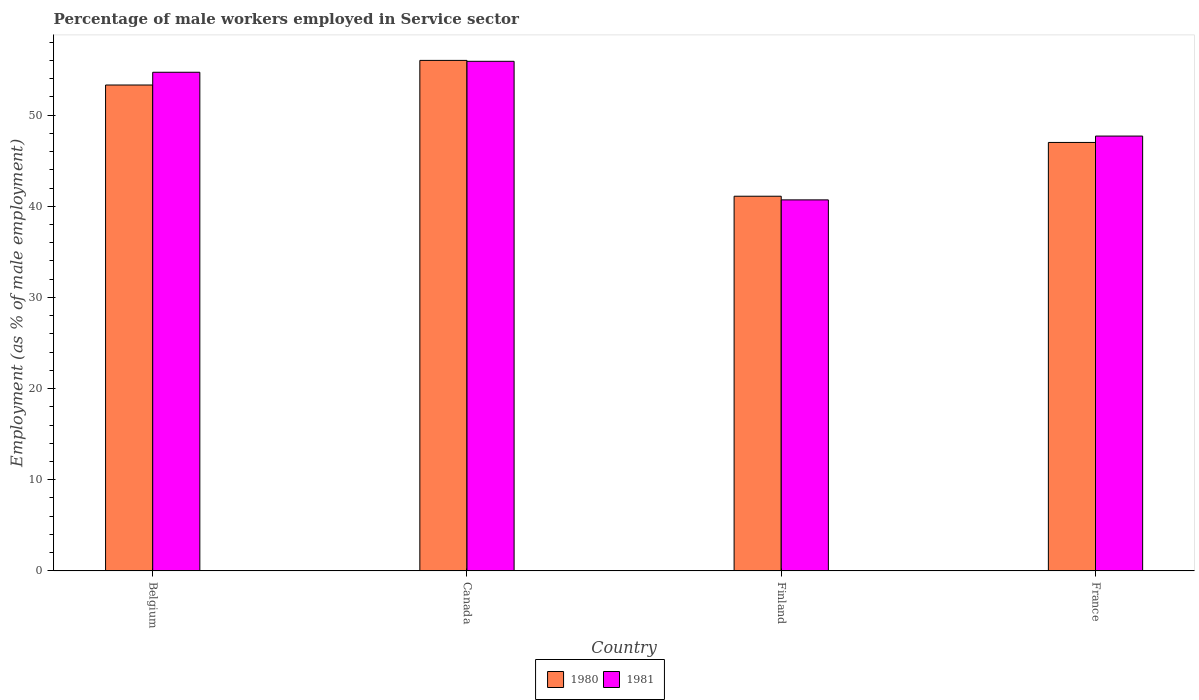How many different coloured bars are there?
Give a very brief answer. 2. How many groups of bars are there?
Ensure brevity in your answer.  4. Are the number of bars per tick equal to the number of legend labels?
Keep it short and to the point. Yes. Are the number of bars on each tick of the X-axis equal?
Offer a very short reply. Yes. How many bars are there on the 2nd tick from the right?
Your answer should be very brief. 2. What is the label of the 3rd group of bars from the left?
Ensure brevity in your answer.  Finland. What is the percentage of male workers employed in Service sector in 1981 in Canada?
Keep it short and to the point. 55.9. Across all countries, what is the maximum percentage of male workers employed in Service sector in 1981?
Provide a succinct answer. 55.9. Across all countries, what is the minimum percentage of male workers employed in Service sector in 1980?
Your answer should be compact. 41.1. In which country was the percentage of male workers employed in Service sector in 1981 maximum?
Provide a succinct answer. Canada. In which country was the percentage of male workers employed in Service sector in 1980 minimum?
Provide a short and direct response. Finland. What is the total percentage of male workers employed in Service sector in 1980 in the graph?
Make the answer very short. 197.4. What is the difference between the percentage of male workers employed in Service sector in 1981 in Finland and the percentage of male workers employed in Service sector in 1980 in Canada?
Keep it short and to the point. -15.3. What is the average percentage of male workers employed in Service sector in 1981 per country?
Keep it short and to the point. 49.75. What is the difference between the percentage of male workers employed in Service sector of/in 1980 and percentage of male workers employed in Service sector of/in 1981 in Canada?
Offer a terse response. 0.1. What is the ratio of the percentage of male workers employed in Service sector in 1981 in Canada to that in Finland?
Offer a terse response. 1.37. Is the percentage of male workers employed in Service sector in 1981 in Canada less than that in Finland?
Provide a succinct answer. No. What is the difference between the highest and the lowest percentage of male workers employed in Service sector in 1980?
Provide a short and direct response. 14.9. How many bars are there?
Your answer should be compact. 8. Are all the bars in the graph horizontal?
Ensure brevity in your answer.  No. How many countries are there in the graph?
Make the answer very short. 4. Are the values on the major ticks of Y-axis written in scientific E-notation?
Ensure brevity in your answer.  No. Where does the legend appear in the graph?
Your answer should be compact. Bottom center. What is the title of the graph?
Make the answer very short. Percentage of male workers employed in Service sector. What is the label or title of the X-axis?
Give a very brief answer. Country. What is the label or title of the Y-axis?
Make the answer very short. Employment (as % of male employment). What is the Employment (as % of male employment) of 1980 in Belgium?
Provide a succinct answer. 53.3. What is the Employment (as % of male employment) in 1981 in Belgium?
Offer a terse response. 54.7. What is the Employment (as % of male employment) in 1981 in Canada?
Ensure brevity in your answer.  55.9. What is the Employment (as % of male employment) in 1980 in Finland?
Offer a terse response. 41.1. What is the Employment (as % of male employment) in 1981 in Finland?
Your response must be concise. 40.7. What is the Employment (as % of male employment) in 1981 in France?
Keep it short and to the point. 47.7. Across all countries, what is the maximum Employment (as % of male employment) in 1981?
Make the answer very short. 55.9. Across all countries, what is the minimum Employment (as % of male employment) in 1980?
Your answer should be very brief. 41.1. Across all countries, what is the minimum Employment (as % of male employment) in 1981?
Your answer should be compact. 40.7. What is the total Employment (as % of male employment) of 1980 in the graph?
Give a very brief answer. 197.4. What is the total Employment (as % of male employment) of 1981 in the graph?
Offer a terse response. 199. What is the difference between the Employment (as % of male employment) in 1981 in Belgium and that in Canada?
Your answer should be compact. -1.2. What is the difference between the Employment (as % of male employment) in 1980 in Belgium and that in Finland?
Your answer should be very brief. 12.2. What is the difference between the Employment (as % of male employment) in 1981 in Belgium and that in Finland?
Your response must be concise. 14. What is the difference between the Employment (as % of male employment) of 1980 in Finland and that in France?
Keep it short and to the point. -5.9. What is the difference between the Employment (as % of male employment) of 1981 in Finland and that in France?
Provide a succinct answer. -7. What is the difference between the Employment (as % of male employment) of 1980 in Belgium and the Employment (as % of male employment) of 1981 in Canada?
Your response must be concise. -2.6. What is the difference between the Employment (as % of male employment) of 1980 in Belgium and the Employment (as % of male employment) of 1981 in France?
Offer a very short reply. 5.6. What is the difference between the Employment (as % of male employment) of 1980 in Canada and the Employment (as % of male employment) of 1981 in Finland?
Ensure brevity in your answer.  15.3. What is the difference between the Employment (as % of male employment) in 1980 in Finland and the Employment (as % of male employment) in 1981 in France?
Offer a terse response. -6.6. What is the average Employment (as % of male employment) of 1980 per country?
Give a very brief answer. 49.35. What is the average Employment (as % of male employment) of 1981 per country?
Your response must be concise. 49.75. What is the difference between the Employment (as % of male employment) in 1980 and Employment (as % of male employment) in 1981 in Belgium?
Your answer should be compact. -1.4. What is the ratio of the Employment (as % of male employment) in 1980 in Belgium to that in Canada?
Offer a very short reply. 0.95. What is the ratio of the Employment (as % of male employment) in 1981 in Belgium to that in Canada?
Make the answer very short. 0.98. What is the ratio of the Employment (as % of male employment) of 1980 in Belgium to that in Finland?
Keep it short and to the point. 1.3. What is the ratio of the Employment (as % of male employment) of 1981 in Belgium to that in Finland?
Your answer should be very brief. 1.34. What is the ratio of the Employment (as % of male employment) in 1980 in Belgium to that in France?
Your answer should be compact. 1.13. What is the ratio of the Employment (as % of male employment) in 1981 in Belgium to that in France?
Provide a succinct answer. 1.15. What is the ratio of the Employment (as % of male employment) in 1980 in Canada to that in Finland?
Provide a succinct answer. 1.36. What is the ratio of the Employment (as % of male employment) in 1981 in Canada to that in Finland?
Your response must be concise. 1.37. What is the ratio of the Employment (as % of male employment) in 1980 in Canada to that in France?
Provide a succinct answer. 1.19. What is the ratio of the Employment (as % of male employment) in 1981 in Canada to that in France?
Keep it short and to the point. 1.17. What is the ratio of the Employment (as % of male employment) of 1980 in Finland to that in France?
Make the answer very short. 0.87. What is the ratio of the Employment (as % of male employment) of 1981 in Finland to that in France?
Offer a very short reply. 0.85. What is the difference between the highest and the second highest Employment (as % of male employment) of 1980?
Ensure brevity in your answer.  2.7. What is the difference between the highest and the lowest Employment (as % of male employment) in 1980?
Ensure brevity in your answer.  14.9. What is the difference between the highest and the lowest Employment (as % of male employment) of 1981?
Offer a very short reply. 15.2. 